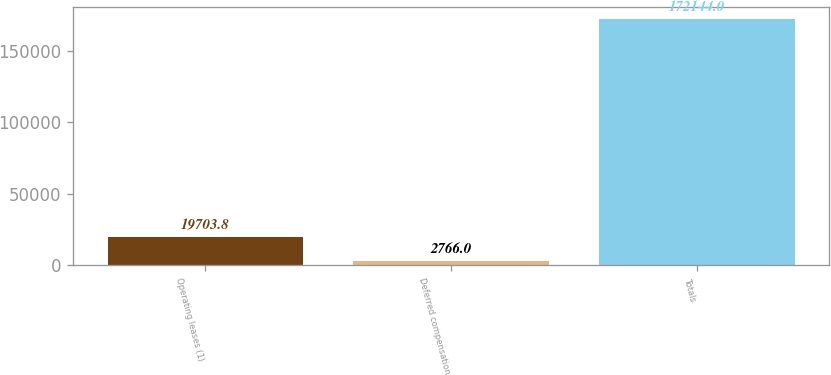Convert chart to OTSL. <chart><loc_0><loc_0><loc_500><loc_500><bar_chart><fcel>Operating leases (1)<fcel>Deferred compensation<fcel>Totals<nl><fcel>19703.8<fcel>2766<fcel>172144<nl></chart> 